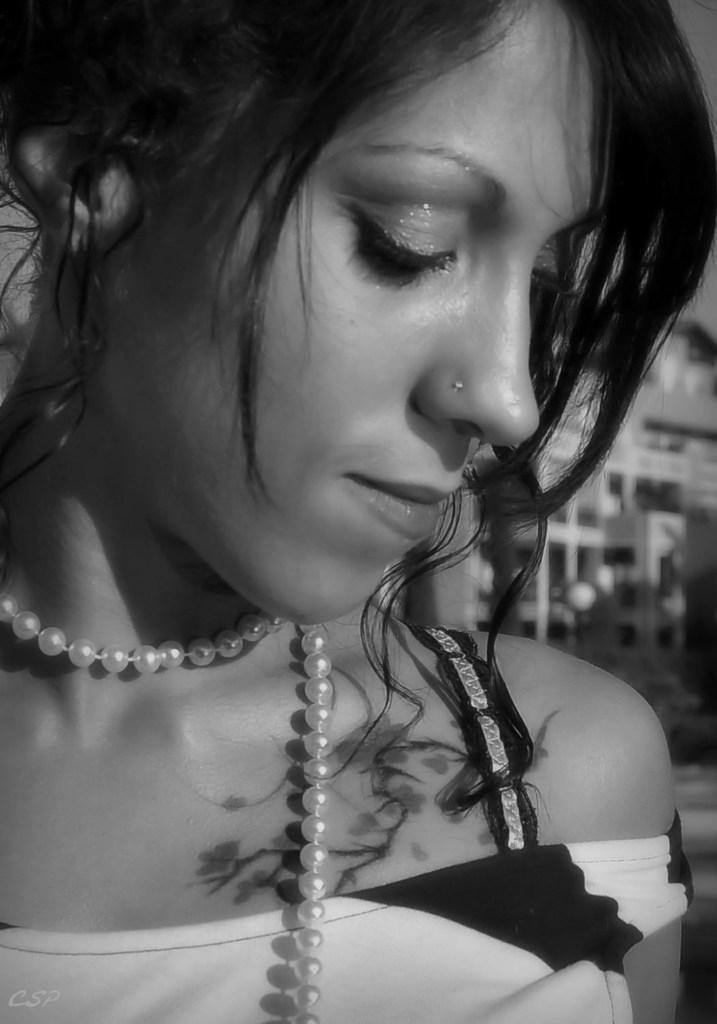Could you give a brief overview of what you see in this image? It is a black and white image and there is a woman in the foreground. 